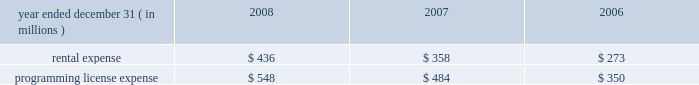The table summarizes our rental expense and program- ming license expense charged to operations: .
Contingencies we and the minority owner group in comcast spectacor each have the right to initiate an exit process under which the fair mar- ket value of comcast spectacor would be determined by appraisal .
Following such determination , we would have the option to acquire the 24.3% ( 24.3 % ) interest in comcast spectacor owned by the minority owner group based on the appraised fair market value .
In the event we do not exercise this option , we and the minority owner group would then be required to use our best efforts to sell comcast spectacor .
This exit process includes the minority owner group 2019s interest in comcast sportsnet ( philadelphia ) .
The minority owners in certain of our technology development ventures also have rights to trigger an exit process after a certain period of time based on the fair value of the entities at the time the exit process is triggered .
Antitrust cases we are defendants in two purported class actions originally filed in december 2003 in the united states district courts for the district of massachusetts and the eastern district of pennsylvania .
The potential class in the massachusetts case is our subscriber base in the 201cboston cluster 201d area , and the potential class in the pennsylvania case is our subscriber base in the 201cphiladelphia and chicago clusters , 201d as those terms are defined in the complaints .
In each case , the plaintiffs allege that certain subscriber exchange transactions with other cable providers resulted in unlawful horizontal market restraints in those areas and seek damages under antitrust statutes , including treble damages .
Our motion to dismiss the pennsylvania case on the pleadings was denied in december 2006 and classes of philadelphia cluster and chicago cluster subscribers were certified in may 2007 and october 2007 , respectively .
Our motion to dismiss the massachu- setts case , which was transferred to the eastern district of pennsylvania in december 2006 , was denied in july 2007 .
We are proceeding with discovery on plaintiffs 2019 claims concerning the philadelphia cluster .
Plaintiffs 2019 claims concerning the other two clusters are stayed pending determination of the philadelphia cluster claims .
In addition , we are among the defendants in a purported class action filed in the united states district court for the central dis- trict of california ( 201ccentral district 201d ) in september 2007 .
The plaintiffs allege that the defendants who produce video program- ming have entered into agreements with the defendants who distribute video programming via cable and satellite ( including us , among others ) , which preclude the distributors from reselling channels to subscribers on an 201cunbundled 201d basis in violation of federal antitrust laws .
The plaintiffs seek treble damages for the loss of their ability to pick and choose the specific 201cbundled 201d channels to which they wish to subscribe , and injunctive relief requiring each distributor defendant to resell certain channels to its subscribers on an 201cunbundled 201d basis .
The potential class is com- prised of all persons residing in the united states who have subscribed to an expanded basic level of video service provided by one of the distributor defendants .
We and the other defendants filed motions to dismiss an amended complaint in april 2008 .
In june 2008 , the central district denied the motions to dismiss .
In july 2008 , we and the other defendants filed motions to certify certain issues decided in the central district 2019s june 2008 order for interlocutory appeal to the ninth circuit court of appeals .
On august 8 , 2008 , the central district denied the certification motions .
In january 2009 , the central district approved a stip- ulation between the parties dismissing the action as to one of the two plaintiffs identified in the amended complaint as a comcast subscriber .
Discovery relevant to plaintiffs 2019 anticipated motion for class certification is currently proceeding , with plaintiffs scheduled to file their class certification motion in april 2009 .
Securities and related litigation we and several of our current and former officers were named as defendants in a purported class action lawsuit filed in the united states district court for the eastern district of pennsylvania ( 201ceastern district 201d ) in january 2008 .
We filed a motion to dismiss the case in february 2008 .
The plaintiff did not respond , but instead sought leave to amend the complaint , which the court granted .
The plaintiff filed an amended complaint in may 2008 naming only us and two current officers as defendants .
The alleged class was comprised of purchasers of our publicly issued securities between february 1 , 2007 and december 4 , 2007 .
The plaintiff asserted that during the alleged class period , the defend- ants violated federal securities laws through alleged material misstatements and omissions relating to forecast results for 2007 .
The plaintiff sought unspecified damages .
In june 2008 , we filed a motion to dismiss the amended complaint .
In an order dated august 25 , 2008 , the court granted our motion to dismiss and denied the plaintiff permission to amend the complaint again .
The plaintiff has not timely appealed the court 2019s decision , so the dis- missal of this case is final .
We and several of our current officers have been named as defend- ants in a separate purported class action lawsuit filed in the eastern district in february 2008 .
The alleged class comprises participants in our retirement-investment ( 401 ( k ) ) plan that invested in the plan 2019s company stock account .
The plaintiff asserts that the defendants breached their fiduciary duties in managing the plan .
The plaintiff seeks unspecified damages .
The plaintiff filed an amended complaint in june 2008 , and in july 2008 we filed a motion to dismiss the amended complaint .
On october 29 , 2008 , 67 comcast 2008 annual report on form 10-k .
In 2008 what was the ratio of the rental expense to the programming license expense? 
Computations: (436 / 548)
Answer: 0.79562. 